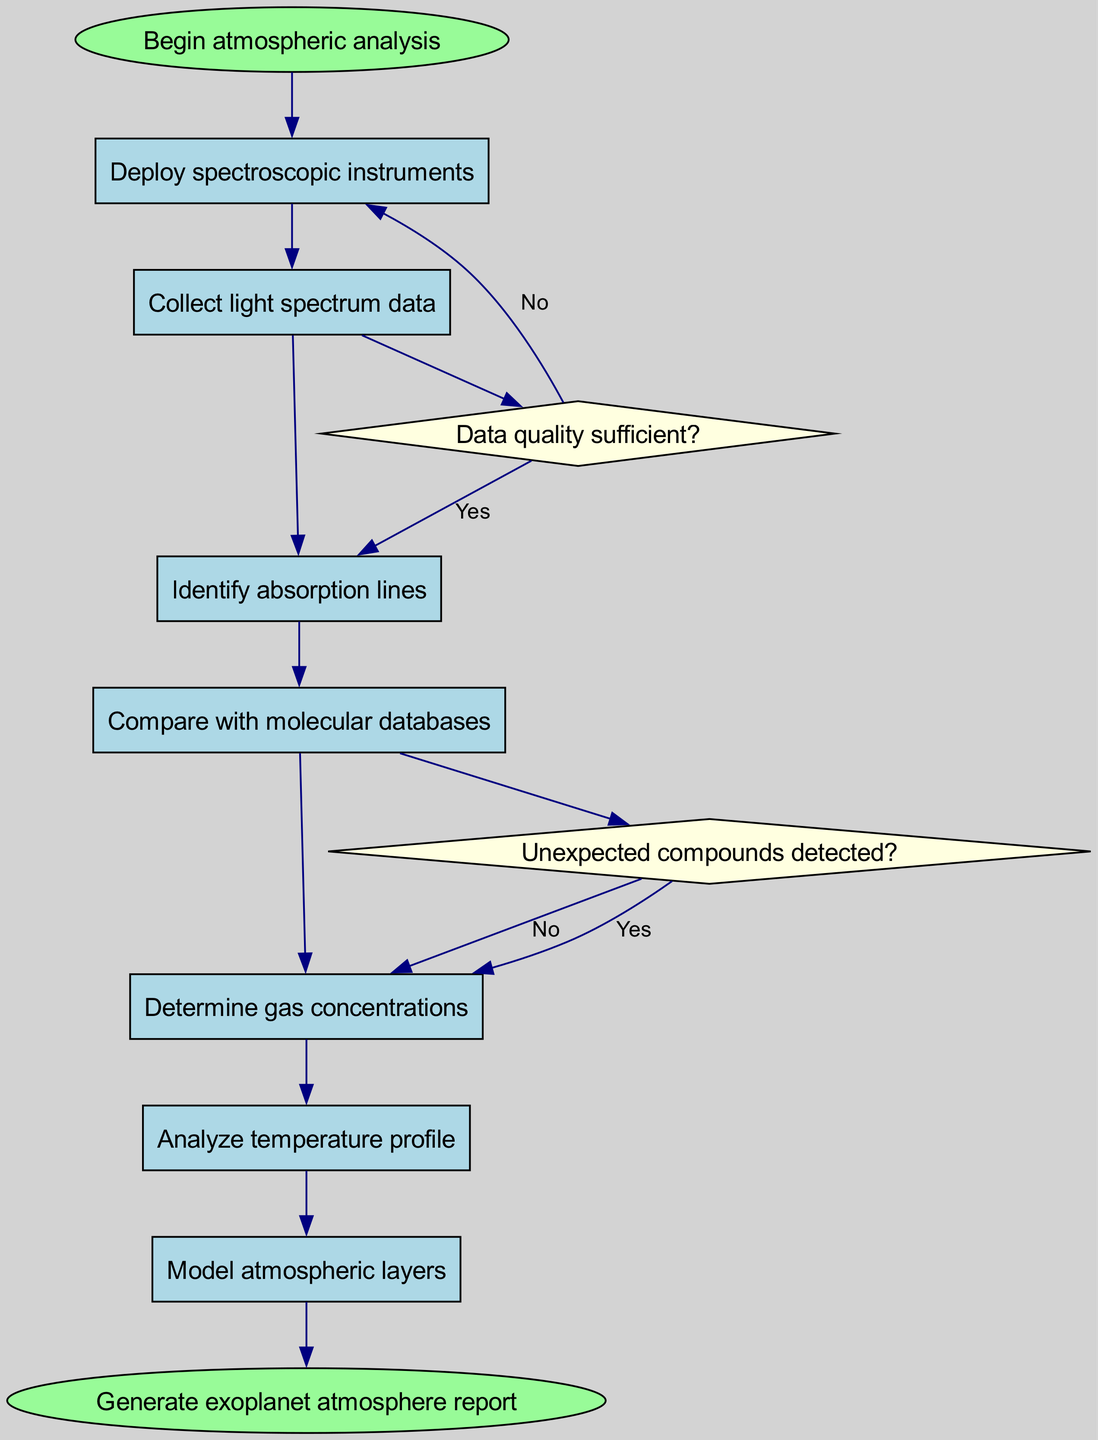What's the first step in the atmospheric analysis? The diagram indicates that the first step is labeled 'Begin atmospheric analysis'. After this starting point, the flow proceeds to the first process node which is 'Deploy spectroscopic instruments'.
Answer: Deploy spectroscopic instruments How many nodes are there in total in the diagram? The diagram contains a total of 8 nodes: 6 process nodes, 2 decision nodes, and 2 start/end nodes. Adding these gives us 8 altogether.
Answer: 8 What happens if the data quality is insufficient? The decision node for 'Data quality sufficient?' shows that if the answer is 'No', the flow leads to 'Recalibrate instruments', indicating this action is taken when data quality is lacking.
Answer: Recalibrate instruments Which node follows 'Collect light spectrum data'? Following the 'Collect light spectrum data' node, the next node in the flow chart is 'Identify absorption lines'. This follows the logical progression in the atmospheric analysis process.
Answer: Identify absorption lines What is the last action taken before generating the report? The final process node before reaching the 'Generate exoplanet atmosphere report' node is 'Model atmospheric layers', indicating that modeling is the last analytical step in the process.
Answer: Model atmospheric layers What occurs if unexpected compounds are detected? According to the diagram, if unexpected compounds are detected, the flow indicates that the next step would be to 'Investigate potential biosignatures', showing an exploratory action in response to unexpected findings.
Answer: Investigate potential biosignatures How does the analysis progress from the temperature profile? After 'Analyze temperature profile', the flow progresses to 'Model atmospheric layers', showing that modeling is directly informed by the analysis of the temperature profile, hence demonstrating a sequence of analysis.
Answer: Model atmospheric layers What is the relationship between 'Identify absorption lines' and 'Compare with molecular databases'? The diagram links 'Identify absorption lines' directly to 'Compare with molecular databases', indicating that the identification of lines is a precursor step leading to the comparison needed for further analysis.
Answer: Directly linked 